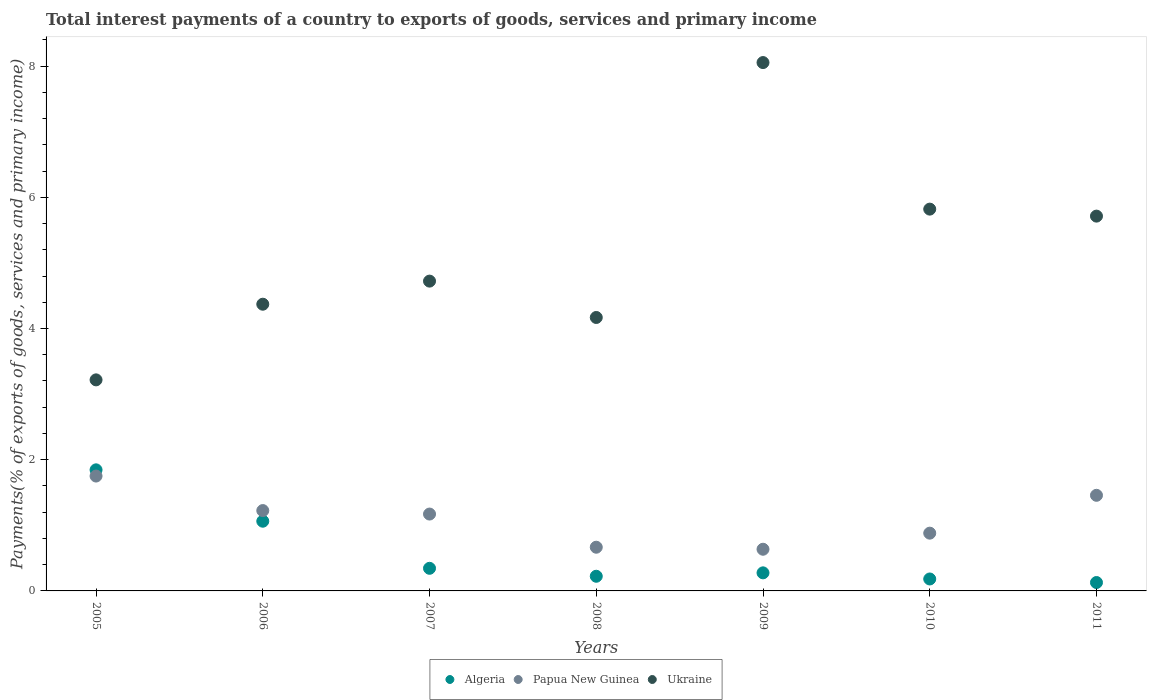How many different coloured dotlines are there?
Make the answer very short. 3. What is the total interest payments in Algeria in 2008?
Your answer should be compact. 0.22. Across all years, what is the maximum total interest payments in Papua New Guinea?
Keep it short and to the point. 1.75. Across all years, what is the minimum total interest payments in Papua New Guinea?
Provide a short and direct response. 0.64. In which year was the total interest payments in Papua New Guinea maximum?
Your answer should be compact. 2005. What is the total total interest payments in Algeria in the graph?
Give a very brief answer. 4.06. What is the difference between the total interest payments in Papua New Guinea in 2006 and that in 2010?
Your answer should be very brief. 0.34. What is the difference between the total interest payments in Algeria in 2008 and the total interest payments in Ukraine in 2009?
Provide a succinct answer. -7.83. What is the average total interest payments in Papua New Guinea per year?
Provide a short and direct response. 1.11. In the year 2010, what is the difference between the total interest payments in Algeria and total interest payments in Ukraine?
Keep it short and to the point. -5.64. In how many years, is the total interest payments in Ukraine greater than 3.2 %?
Provide a short and direct response. 7. What is the ratio of the total interest payments in Papua New Guinea in 2006 to that in 2007?
Offer a very short reply. 1.05. Is the total interest payments in Papua New Guinea in 2005 less than that in 2007?
Your answer should be very brief. No. What is the difference between the highest and the second highest total interest payments in Algeria?
Your response must be concise. 0.78. What is the difference between the highest and the lowest total interest payments in Ukraine?
Ensure brevity in your answer.  4.84. In how many years, is the total interest payments in Ukraine greater than the average total interest payments in Ukraine taken over all years?
Offer a very short reply. 3. Is it the case that in every year, the sum of the total interest payments in Papua New Guinea and total interest payments in Algeria  is greater than the total interest payments in Ukraine?
Keep it short and to the point. No. Is the total interest payments in Ukraine strictly greater than the total interest payments in Papua New Guinea over the years?
Keep it short and to the point. Yes. Is the total interest payments in Papua New Guinea strictly less than the total interest payments in Ukraine over the years?
Provide a short and direct response. Yes. What is the difference between two consecutive major ticks on the Y-axis?
Your response must be concise. 2. Are the values on the major ticks of Y-axis written in scientific E-notation?
Offer a very short reply. No. Does the graph contain any zero values?
Your response must be concise. No. Does the graph contain grids?
Give a very brief answer. No. How many legend labels are there?
Your answer should be compact. 3. How are the legend labels stacked?
Offer a terse response. Horizontal. What is the title of the graph?
Keep it short and to the point. Total interest payments of a country to exports of goods, services and primary income. What is the label or title of the X-axis?
Offer a very short reply. Years. What is the label or title of the Y-axis?
Your response must be concise. Payments(% of exports of goods, services and primary income). What is the Payments(% of exports of goods, services and primary income) in Algeria in 2005?
Offer a very short reply. 1.85. What is the Payments(% of exports of goods, services and primary income) in Papua New Guinea in 2005?
Offer a very short reply. 1.75. What is the Payments(% of exports of goods, services and primary income) of Ukraine in 2005?
Provide a short and direct response. 3.22. What is the Payments(% of exports of goods, services and primary income) in Algeria in 2006?
Your response must be concise. 1.06. What is the Payments(% of exports of goods, services and primary income) in Papua New Guinea in 2006?
Your response must be concise. 1.22. What is the Payments(% of exports of goods, services and primary income) in Ukraine in 2006?
Provide a short and direct response. 4.37. What is the Payments(% of exports of goods, services and primary income) in Algeria in 2007?
Your answer should be compact. 0.34. What is the Payments(% of exports of goods, services and primary income) in Papua New Guinea in 2007?
Keep it short and to the point. 1.17. What is the Payments(% of exports of goods, services and primary income) of Ukraine in 2007?
Keep it short and to the point. 4.72. What is the Payments(% of exports of goods, services and primary income) in Algeria in 2008?
Offer a very short reply. 0.22. What is the Payments(% of exports of goods, services and primary income) in Papua New Guinea in 2008?
Your answer should be very brief. 0.67. What is the Payments(% of exports of goods, services and primary income) in Ukraine in 2008?
Your answer should be compact. 4.17. What is the Payments(% of exports of goods, services and primary income) of Algeria in 2009?
Your answer should be very brief. 0.28. What is the Payments(% of exports of goods, services and primary income) in Papua New Guinea in 2009?
Your answer should be compact. 0.64. What is the Payments(% of exports of goods, services and primary income) in Ukraine in 2009?
Keep it short and to the point. 8.05. What is the Payments(% of exports of goods, services and primary income) in Algeria in 2010?
Keep it short and to the point. 0.18. What is the Payments(% of exports of goods, services and primary income) in Papua New Guinea in 2010?
Provide a succinct answer. 0.88. What is the Payments(% of exports of goods, services and primary income) of Ukraine in 2010?
Your answer should be compact. 5.82. What is the Payments(% of exports of goods, services and primary income) of Algeria in 2011?
Provide a short and direct response. 0.13. What is the Payments(% of exports of goods, services and primary income) in Papua New Guinea in 2011?
Offer a terse response. 1.46. What is the Payments(% of exports of goods, services and primary income) in Ukraine in 2011?
Your response must be concise. 5.71. Across all years, what is the maximum Payments(% of exports of goods, services and primary income) in Algeria?
Make the answer very short. 1.85. Across all years, what is the maximum Payments(% of exports of goods, services and primary income) in Papua New Guinea?
Provide a short and direct response. 1.75. Across all years, what is the maximum Payments(% of exports of goods, services and primary income) of Ukraine?
Your answer should be compact. 8.05. Across all years, what is the minimum Payments(% of exports of goods, services and primary income) in Algeria?
Your answer should be very brief. 0.13. Across all years, what is the minimum Payments(% of exports of goods, services and primary income) of Papua New Guinea?
Keep it short and to the point. 0.64. Across all years, what is the minimum Payments(% of exports of goods, services and primary income) in Ukraine?
Ensure brevity in your answer.  3.22. What is the total Payments(% of exports of goods, services and primary income) of Algeria in the graph?
Your answer should be very brief. 4.06. What is the total Payments(% of exports of goods, services and primary income) of Papua New Guinea in the graph?
Make the answer very short. 7.79. What is the total Payments(% of exports of goods, services and primary income) in Ukraine in the graph?
Provide a succinct answer. 36.06. What is the difference between the Payments(% of exports of goods, services and primary income) in Algeria in 2005 and that in 2006?
Offer a terse response. 0.78. What is the difference between the Payments(% of exports of goods, services and primary income) of Papua New Guinea in 2005 and that in 2006?
Make the answer very short. 0.53. What is the difference between the Payments(% of exports of goods, services and primary income) of Ukraine in 2005 and that in 2006?
Your response must be concise. -1.15. What is the difference between the Payments(% of exports of goods, services and primary income) in Algeria in 2005 and that in 2007?
Ensure brevity in your answer.  1.5. What is the difference between the Payments(% of exports of goods, services and primary income) in Papua New Guinea in 2005 and that in 2007?
Provide a short and direct response. 0.58. What is the difference between the Payments(% of exports of goods, services and primary income) of Ukraine in 2005 and that in 2007?
Ensure brevity in your answer.  -1.51. What is the difference between the Payments(% of exports of goods, services and primary income) in Algeria in 2005 and that in 2008?
Keep it short and to the point. 1.62. What is the difference between the Payments(% of exports of goods, services and primary income) of Papua New Guinea in 2005 and that in 2008?
Ensure brevity in your answer.  1.08. What is the difference between the Payments(% of exports of goods, services and primary income) in Ukraine in 2005 and that in 2008?
Offer a terse response. -0.95. What is the difference between the Payments(% of exports of goods, services and primary income) in Algeria in 2005 and that in 2009?
Offer a terse response. 1.57. What is the difference between the Payments(% of exports of goods, services and primary income) in Papua New Guinea in 2005 and that in 2009?
Provide a succinct answer. 1.12. What is the difference between the Payments(% of exports of goods, services and primary income) in Ukraine in 2005 and that in 2009?
Your answer should be compact. -4.84. What is the difference between the Payments(% of exports of goods, services and primary income) of Algeria in 2005 and that in 2010?
Your response must be concise. 1.66. What is the difference between the Payments(% of exports of goods, services and primary income) in Papua New Guinea in 2005 and that in 2010?
Keep it short and to the point. 0.87. What is the difference between the Payments(% of exports of goods, services and primary income) in Ukraine in 2005 and that in 2010?
Provide a succinct answer. -2.6. What is the difference between the Payments(% of exports of goods, services and primary income) of Algeria in 2005 and that in 2011?
Offer a terse response. 1.72. What is the difference between the Payments(% of exports of goods, services and primary income) of Papua New Guinea in 2005 and that in 2011?
Ensure brevity in your answer.  0.29. What is the difference between the Payments(% of exports of goods, services and primary income) in Ukraine in 2005 and that in 2011?
Provide a short and direct response. -2.5. What is the difference between the Payments(% of exports of goods, services and primary income) in Algeria in 2006 and that in 2007?
Ensure brevity in your answer.  0.72. What is the difference between the Payments(% of exports of goods, services and primary income) of Papua New Guinea in 2006 and that in 2007?
Your response must be concise. 0.05. What is the difference between the Payments(% of exports of goods, services and primary income) in Ukraine in 2006 and that in 2007?
Make the answer very short. -0.35. What is the difference between the Payments(% of exports of goods, services and primary income) in Algeria in 2006 and that in 2008?
Make the answer very short. 0.84. What is the difference between the Payments(% of exports of goods, services and primary income) in Papua New Guinea in 2006 and that in 2008?
Your response must be concise. 0.56. What is the difference between the Payments(% of exports of goods, services and primary income) of Ukraine in 2006 and that in 2008?
Provide a succinct answer. 0.2. What is the difference between the Payments(% of exports of goods, services and primary income) in Algeria in 2006 and that in 2009?
Offer a terse response. 0.79. What is the difference between the Payments(% of exports of goods, services and primary income) of Papua New Guinea in 2006 and that in 2009?
Give a very brief answer. 0.59. What is the difference between the Payments(% of exports of goods, services and primary income) in Ukraine in 2006 and that in 2009?
Provide a short and direct response. -3.68. What is the difference between the Payments(% of exports of goods, services and primary income) of Algeria in 2006 and that in 2010?
Offer a very short reply. 0.88. What is the difference between the Payments(% of exports of goods, services and primary income) in Papua New Guinea in 2006 and that in 2010?
Offer a terse response. 0.34. What is the difference between the Payments(% of exports of goods, services and primary income) of Ukraine in 2006 and that in 2010?
Your response must be concise. -1.45. What is the difference between the Payments(% of exports of goods, services and primary income) of Algeria in 2006 and that in 2011?
Make the answer very short. 0.93. What is the difference between the Payments(% of exports of goods, services and primary income) in Papua New Guinea in 2006 and that in 2011?
Keep it short and to the point. -0.23. What is the difference between the Payments(% of exports of goods, services and primary income) in Ukraine in 2006 and that in 2011?
Your answer should be compact. -1.34. What is the difference between the Payments(% of exports of goods, services and primary income) of Algeria in 2007 and that in 2008?
Ensure brevity in your answer.  0.12. What is the difference between the Payments(% of exports of goods, services and primary income) of Papua New Guinea in 2007 and that in 2008?
Provide a succinct answer. 0.51. What is the difference between the Payments(% of exports of goods, services and primary income) of Ukraine in 2007 and that in 2008?
Offer a terse response. 0.55. What is the difference between the Payments(% of exports of goods, services and primary income) of Algeria in 2007 and that in 2009?
Ensure brevity in your answer.  0.07. What is the difference between the Payments(% of exports of goods, services and primary income) in Papua New Guinea in 2007 and that in 2009?
Offer a terse response. 0.54. What is the difference between the Payments(% of exports of goods, services and primary income) in Ukraine in 2007 and that in 2009?
Provide a short and direct response. -3.33. What is the difference between the Payments(% of exports of goods, services and primary income) of Algeria in 2007 and that in 2010?
Make the answer very short. 0.16. What is the difference between the Payments(% of exports of goods, services and primary income) of Papua New Guinea in 2007 and that in 2010?
Offer a terse response. 0.29. What is the difference between the Payments(% of exports of goods, services and primary income) of Ukraine in 2007 and that in 2010?
Provide a short and direct response. -1.1. What is the difference between the Payments(% of exports of goods, services and primary income) of Algeria in 2007 and that in 2011?
Offer a terse response. 0.22. What is the difference between the Payments(% of exports of goods, services and primary income) in Papua New Guinea in 2007 and that in 2011?
Make the answer very short. -0.29. What is the difference between the Payments(% of exports of goods, services and primary income) of Ukraine in 2007 and that in 2011?
Offer a very short reply. -0.99. What is the difference between the Payments(% of exports of goods, services and primary income) of Algeria in 2008 and that in 2009?
Your response must be concise. -0.05. What is the difference between the Payments(% of exports of goods, services and primary income) in Papua New Guinea in 2008 and that in 2009?
Offer a terse response. 0.03. What is the difference between the Payments(% of exports of goods, services and primary income) in Ukraine in 2008 and that in 2009?
Ensure brevity in your answer.  -3.89. What is the difference between the Payments(% of exports of goods, services and primary income) of Algeria in 2008 and that in 2010?
Offer a terse response. 0.04. What is the difference between the Payments(% of exports of goods, services and primary income) of Papua New Guinea in 2008 and that in 2010?
Provide a short and direct response. -0.21. What is the difference between the Payments(% of exports of goods, services and primary income) in Ukraine in 2008 and that in 2010?
Keep it short and to the point. -1.65. What is the difference between the Payments(% of exports of goods, services and primary income) of Algeria in 2008 and that in 2011?
Offer a very short reply. 0.1. What is the difference between the Payments(% of exports of goods, services and primary income) of Papua New Guinea in 2008 and that in 2011?
Provide a short and direct response. -0.79. What is the difference between the Payments(% of exports of goods, services and primary income) of Ukraine in 2008 and that in 2011?
Make the answer very short. -1.54. What is the difference between the Payments(% of exports of goods, services and primary income) of Algeria in 2009 and that in 2010?
Provide a succinct answer. 0.09. What is the difference between the Payments(% of exports of goods, services and primary income) of Papua New Guinea in 2009 and that in 2010?
Make the answer very short. -0.25. What is the difference between the Payments(% of exports of goods, services and primary income) of Ukraine in 2009 and that in 2010?
Your answer should be very brief. 2.23. What is the difference between the Payments(% of exports of goods, services and primary income) of Algeria in 2009 and that in 2011?
Your answer should be very brief. 0.15. What is the difference between the Payments(% of exports of goods, services and primary income) of Papua New Guinea in 2009 and that in 2011?
Your response must be concise. -0.82. What is the difference between the Payments(% of exports of goods, services and primary income) of Ukraine in 2009 and that in 2011?
Keep it short and to the point. 2.34. What is the difference between the Payments(% of exports of goods, services and primary income) of Algeria in 2010 and that in 2011?
Give a very brief answer. 0.05. What is the difference between the Payments(% of exports of goods, services and primary income) of Papua New Guinea in 2010 and that in 2011?
Offer a very short reply. -0.58. What is the difference between the Payments(% of exports of goods, services and primary income) in Ukraine in 2010 and that in 2011?
Ensure brevity in your answer.  0.11. What is the difference between the Payments(% of exports of goods, services and primary income) in Algeria in 2005 and the Payments(% of exports of goods, services and primary income) in Papua New Guinea in 2006?
Offer a very short reply. 0.62. What is the difference between the Payments(% of exports of goods, services and primary income) in Algeria in 2005 and the Payments(% of exports of goods, services and primary income) in Ukraine in 2006?
Keep it short and to the point. -2.52. What is the difference between the Payments(% of exports of goods, services and primary income) of Papua New Guinea in 2005 and the Payments(% of exports of goods, services and primary income) of Ukraine in 2006?
Offer a very short reply. -2.62. What is the difference between the Payments(% of exports of goods, services and primary income) in Algeria in 2005 and the Payments(% of exports of goods, services and primary income) in Papua New Guinea in 2007?
Provide a succinct answer. 0.67. What is the difference between the Payments(% of exports of goods, services and primary income) in Algeria in 2005 and the Payments(% of exports of goods, services and primary income) in Ukraine in 2007?
Your answer should be very brief. -2.88. What is the difference between the Payments(% of exports of goods, services and primary income) of Papua New Guinea in 2005 and the Payments(% of exports of goods, services and primary income) of Ukraine in 2007?
Keep it short and to the point. -2.97. What is the difference between the Payments(% of exports of goods, services and primary income) in Algeria in 2005 and the Payments(% of exports of goods, services and primary income) in Papua New Guinea in 2008?
Provide a short and direct response. 1.18. What is the difference between the Payments(% of exports of goods, services and primary income) of Algeria in 2005 and the Payments(% of exports of goods, services and primary income) of Ukraine in 2008?
Provide a succinct answer. -2.32. What is the difference between the Payments(% of exports of goods, services and primary income) in Papua New Guinea in 2005 and the Payments(% of exports of goods, services and primary income) in Ukraine in 2008?
Provide a short and direct response. -2.42. What is the difference between the Payments(% of exports of goods, services and primary income) in Algeria in 2005 and the Payments(% of exports of goods, services and primary income) in Papua New Guinea in 2009?
Give a very brief answer. 1.21. What is the difference between the Payments(% of exports of goods, services and primary income) in Algeria in 2005 and the Payments(% of exports of goods, services and primary income) in Ukraine in 2009?
Your answer should be very brief. -6.21. What is the difference between the Payments(% of exports of goods, services and primary income) of Papua New Guinea in 2005 and the Payments(% of exports of goods, services and primary income) of Ukraine in 2009?
Ensure brevity in your answer.  -6.3. What is the difference between the Payments(% of exports of goods, services and primary income) of Algeria in 2005 and the Payments(% of exports of goods, services and primary income) of Papua New Guinea in 2010?
Provide a succinct answer. 0.97. What is the difference between the Payments(% of exports of goods, services and primary income) in Algeria in 2005 and the Payments(% of exports of goods, services and primary income) in Ukraine in 2010?
Keep it short and to the point. -3.97. What is the difference between the Payments(% of exports of goods, services and primary income) of Papua New Guinea in 2005 and the Payments(% of exports of goods, services and primary income) of Ukraine in 2010?
Provide a short and direct response. -4.07. What is the difference between the Payments(% of exports of goods, services and primary income) of Algeria in 2005 and the Payments(% of exports of goods, services and primary income) of Papua New Guinea in 2011?
Offer a very short reply. 0.39. What is the difference between the Payments(% of exports of goods, services and primary income) in Algeria in 2005 and the Payments(% of exports of goods, services and primary income) in Ukraine in 2011?
Provide a short and direct response. -3.87. What is the difference between the Payments(% of exports of goods, services and primary income) of Papua New Guinea in 2005 and the Payments(% of exports of goods, services and primary income) of Ukraine in 2011?
Offer a very short reply. -3.96. What is the difference between the Payments(% of exports of goods, services and primary income) in Algeria in 2006 and the Payments(% of exports of goods, services and primary income) in Papua New Guinea in 2007?
Your answer should be very brief. -0.11. What is the difference between the Payments(% of exports of goods, services and primary income) in Algeria in 2006 and the Payments(% of exports of goods, services and primary income) in Ukraine in 2007?
Your answer should be compact. -3.66. What is the difference between the Payments(% of exports of goods, services and primary income) in Papua New Guinea in 2006 and the Payments(% of exports of goods, services and primary income) in Ukraine in 2007?
Make the answer very short. -3.5. What is the difference between the Payments(% of exports of goods, services and primary income) in Algeria in 2006 and the Payments(% of exports of goods, services and primary income) in Papua New Guinea in 2008?
Your response must be concise. 0.4. What is the difference between the Payments(% of exports of goods, services and primary income) of Algeria in 2006 and the Payments(% of exports of goods, services and primary income) of Ukraine in 2008?
Your answer should be compact. -3.11. What is the difference between the Payments(% of exports of goods, services and primary income) of Papua New Guinea in 2006 and the Payments(% of exports of goods, services and primary income) of Ukraine in 2008?
Give a very brief answer. -2.94. What is the difference between the Payments(% of exports of goods, services and primary income) of Algeria in 2006 and the Payments(% of exports of goods, services and primary income) of Papua New Guinea in 2009?
Ensure brevity in your answer.  0.43. What is the difference between the Payments(% of exports of goods, services and primary income) of Algeria in 2006 and the Payments(% of exports of goods, services and primary income) of Ukraine in 2009?
Provide a short and direct response. -6.99. What is the difference between the Payments(% of exports of goods, services and primary income) in Papua New Guinea in 2006 and the Payments(% of exports of goods, services and primary income) in Ukraine in 2009?
Your answer should be very brief. -6.83. What is the difference between the Payments(% of exports of goods, services and primary income) in Algeria in 2006 and the Payments(% of exports of goods, services and primary income) in Papua New Guinea in 2010?
Give a very brief answer. 0.18. What is the difference between the Payments(% of exports of goods, services and primary income) of Algeria in 2006 and the Payments(% of exports of goods, services and primary income) of Ukraine in 2010?
Provide a short and direct response. -4.76. What is the difference between the Payments(% of exports of goods, services and primary income) of Papua New Guinea in 2006 and the Payments(% of exports of goods, services and primary income) of Ukraine in 2010?
Give a very brief answer. -4.59. What is the difference between the Payments(% of exports of goods, services and primary income) in Algeria in 2006 and the Payments(% of exports of goods, services and primary income) in Papua New Guinea in 2011?
Provide a succinct answer. -0.39. What is the difference between the Payments(% of exports of goods, services and primary income) of Algeria in 2006 and the Payments(% of exports of goods, services and primary income) of Ukraine in 2011?
Provide a succinct answer. -4.65. What is the difference between the Payments(% of exports of goods, services and primary income) of Papua New Guinea in 2006 and the Payments(% of exports of goods, services and primary income) of Ukraine in 2011?
Your answer should be very brief. -4.49. What is the difference between the Payments(% of exports of goods, services and primary income) of Algeria in 2007 and the Payments(% of exports of goods, services and primary income) of Papua New Guinea in 2008?
Provide a succinct answer. -0.32. What is the difference between the Payments(% of exports of goods, services and primary income) of Algeria in 2007 and the Payments(% of exports of goods, services and primary income) of Ukraine in 2008?
Offer a very short reply. -3.82. What is the difference between the Payments(% of exports of goods, services and primary income) of Papua New Guinea in 2007 and the Payments(% of exports of goods, services and primary income) of Ukraine in 2008?
Offer a very short reply. -3. What is the difference between the Payments(% of exports of goods, services and primary income) of Algeria in 2007 and the Payments(% of exports of goods, services and primary income) of Papua New Guinea in 2009?
Offer a very short reply. -0.29. What is the difference between the Payments(% of exports of goods, services and primary income) in Algeria in 2007 and the Payments(% of exports of goods, services and primary income) in Ukraine in 2009?
Make the answer very short. -7.71. What is the difference between the Payments(% of exports of goods, services and primary income) in Papua New Guinea in 2007 and the Payments(% of exports of goods, services and primary income) in Ukraine in 2009?
Your answer should be compact. -6.88. What is the difference between the Payments(% of exports of goods, services and primary income) in Algeria in 2007 and the Payments(% of exports of goods, services and primary income) in Papua New Guinea in 2010?
Your answer should be compact. -0.54. What is the difference between the Payments(% of exports of goods, services and primary income) in Algeria in 2007 and the Payments(% of exports of goods, services and primary income) in Ukraine in 2010?
Offer a terse response. -5.47. What is the difference between the Payments(% of exports of goods, services and primary income) of Papua New Guinea in 2007 and the Payments(% of exports of goods, services and primary income) of Ukraine in 2010?
Provide a short and direct response. -4.65. What is the difference between the Payments(% of exports of goods, services and primary income) in Algeria in 2007 and the Payments(% of exports of goods, services and primary income) in Papua New Guinea in 2011?
Make the answer very short. -1.11. What is the difference between the Payments(% of exports of goods, services and primary income) of Algeria in 2007 and the Payments(% of exports of goods, services and primary income) of Ukraine in 2011?
Offer a very short reply. -5.37. What is the difference between the Payments(% of exports of goods, services and primary income) in Papua New Guinea in 2007 and the Payments(% of exports of goods, services and primary income) in Ukraine in 2011?
Give a very brief answer. -4.54. What is the difference between the Payments(% of exports of goods, services and primary income) in Algeria in 2008 and the Payments(% of exports of goods, services and primary income) in Papua New Guinea in 2009?
Provide a succinct answer. -0.41. What is the difference between the Payments(% of exports of goods, services and primary income) of Algeria in 2008 and the Payments(% of exports of goods, services and primary income) of Ukraine in 2009?
Provide a short and direct response. -7.83. What is the difference between the Payments(% of exports of goods, services and primary income) of Papua New Guinea in 2008 and the Payments(% of exports of goods, services and primary income) of Ukraine in 2009?
Your answer should be very brief. -7.39. What is the difference between the Payments(% of exports of goods, services and primary income) of Algeria in 2008 and the Payments(% of exports of goods, services and primary income) of Papua New Guinea in 2010?
Ensure brevity in your answer.  -0.66. What is the difference between the Payments(% of exports of goods, services and primary income) of Algeria in 2008 and the Payments(% of exports of goods, services and primary income) of Ukraine in 2010?
Your answer should be compact. -5.6. What is the difference between the Payments(% of exports of goods, services and primary income) in Papua New Guinea in 2008 and the Payments(% of exports of goods, services and primary income) in Ukraine in 2010?
Offer a very short reply. -5.15. What is the difference between the Payments(% of exports of goods, services and primary income) of Algeria in 2008 and the Payments(% of exports of goods, services and primary income) of Papua New Guinea in 2011?
Offer a very short reply. -1.23. What is the difference between the Payments(% of exports of goods, services and primary income) of Algeria in 2008 and the Payments(% of exports of goods, services and primary income) of Ukraine in 2011?
Give a very brief answer. -5.49. What is the difference between the Payments(% of exports of goods, services and primary income) of Papua New Guinea in 2008 and the Payments(% of exports of goods, services and primary income) of Ukraine in 2011?
Offer a terse response. -5.05. What is the difference between the Payments(% of exports of goods, services and primary income) of Algeria in 2009 and the Payments(% of exports of goods, services and primary income) of Papua New Guinea in 2010?
Ensure brevity in your answer.  -0.6. What is the difference between the Payments(% of exports of goods, services and primary income) in Algeria in 2009 and the Payments(% of exports of goods, services and primary income) in Ukraine in 2010?
Your answer should be compact. -5.54. What is the difference between the Payments(% of exports of goods, services and primary income) in Papua New Guinea in 2009 and the Payments(% of exports of goods, services and primary income) in Ukraine in 2010?
Your answer should be compact. -5.18. What is the difference between the Payments(% of exports of goods, services and primary income) in Algeria in 2009 and the Payments(% of exports of goods, services and primary income) in Papua New Guinea in 2011?
Provide a succinct answer. -1.18. What is the difference between the Payments(% of exports of goods, services and primary income) of Algeria in 2009 and the Payments(% of exports of goods, services and primary income) of Ukraine in 2011?
Provide a short and direct response. -5.44. What is the difference between the Payments(% of exports of goods, services and primary income) of Papua New Guinea in 2009 and the Payments(% of exports of goods, services and primary income) of Ukraine in 2011?
Offer a terse response. -5.08. What is the difference between the Payments(% of exports of goods, services and primary income) in Algeria in 2010 and the Payments(% of exports of goods, services and primary income) in Papua New Guinea in 2011?
Your answer should be compact. -1.28. What is the difference between the Payments(% of exports of goods, services and primary income) in Algeria in 2010 and the Payments(% of exports of goods, services and primary income) in Ukraine in 2011?
Offer a terse response. -5.53. What is the difference between the Payments(% of exports of goods, services and primary income) in Papua New Guinea in 2010 and the Payments(% of exports of goods, services and primary income) in Ukraine in 2011?
Offer a very short reply. -4.83. What is the average Payments(% of exports of goods, services and primary income) in Algeria per year?
Provide a short and direct response. 0.58. What is the average Payments(% of exports of goods, services and primary income) of Papua New Guinea per year?
Your answer should be very brief. 1.11. What is the average Payments(% of exports of goods, services and primary income) in Ukraine per year?
Provide a succinct answer. 5.15. In the year 2005, what is the difference between the Payments(% of exports of goods, services and primary income) of Algeria and Payments(% of exports of goods, services and primary income) of Papua New Guinea?
Offer a terse response. 0.09. In the year 2005, what is the difference between the Payments(% of exports of goods, services and primary income) in Algeria and Payments(% of exports of goods, services and primary income) in Ukraine?
Provide a succinct answer. -1.37. In the year 2005, what is the difference between the Payments(% of exports of goods, services and primary income) in Papua New Guinea and Payments(% of exports of goods, services and primary income) in Ukraine?
Your answer should be very brief. -1.47. In the year 2006, what is the difference between the Payments(% of exports of goods, services and primary income) of Algeria and Payments(% of exports of goods, services and primary income) of Papua New Guinea?
Provide a succinct answer. -0.16. In the year 2006, what is the difference between the Payments(% of exports of goods, services and primary income) of Algeria and Payments(% of exports of goods, services and primary income) of Ukraine?
Your answer should be compact. -3.31. In the year 2006, what is the difference between the Payments(% of exports of goods, services and primary income) of Papua New Guinea and Payments(% of exports of goods, services and primary income) of Ukraine?
Provide a short and direct response. -3.15. In the year 2007, what is the difference between the Payments(% of exports of goods, services and primary income) of Algeria and Payments(% of exports of goods, services and primary income) of Papua New Guinea?
Provide a short and direct response. -0.83. In the year 2007, what is the difference between the Payments(% of exports of goods, services and primary income) of Algeria and Payments(% of exports of goods, services and primary income) of Ukraine?
Ensure brevity in your answer.  -4.38. In the year 2007, what is the difference between the Payments(% of exports of goods, services and primary income) in Papua New Guinea and Payments(% of exports of goods, services and primary income) in Ukraine?
Offer a terse response. -3.55. In the year 2008, what is the difference between the Payments(% of exports of goods, services and primary income) of Algeria and Payments(% of exports of goods, services and primary income) of Papua New Guinea?
Your response must be concise. -0.44. In the year 2008, what is the difference between the Payments(% of exports of goods, services and primary income) in Algeria and Payments(% of exports of goods, services and primary income) in Ukraine?
Offer a very short reply. -3.94. In the year 2008, what is the difference between the Payments(% of exports of goods, services and primary income) of Papua New Guinea and Payments(% of exports of goods, services and primary income) of Ukraine?
Ensure brevity in your answer.  -3.5. In the year 2009, what is the difference between the Payments(% of exports of goods, services and primary income) of Algeria and Payments(% of exports of goods, services and primary income) of Papua New Guinea?
Provide a succinct answer. -0.36. In the year 2009, what is the difference between the Payments(% of exports of goods, services and primary income) of Algeria and Payments(% of exports of goods, services and primary income) of Ukraine?
Your answer should be compact. -7.78. In the year 2009, what is the difference between the Payments(% of exports of goods, services and primary income) in Papua New Guinea and Payments(% of exports of goods, services and primary income) in Ukraine?
Provide a succinct answer. -7.42. In the year 2010, what is the difference between the Payments(% of exports of goods, services and primary income) of Algeria and Payments(% of exports of goods, services and primary income) of Papua New Guinea?
Offer a very short reply. -0.7. In the year 2010, what is the difference between the Payments(% of exports of goods, services and primary income) in Algeria and Payments(% of exports of goods, services and primary income) in Ukraine?
Make the answer very short. -5.64. In the year 2010, what is the difference between the Payments(% of exports of goods, services and primary income) in Papua New Guinea and Payments(% of exports of goods, services and primary income) in Ukraine?
Offer a terse response. -4.94. In the year 2011, what is the difference between the Payments(% of exports of goods, services and primary income) in Algeria and Payments(% of exports of goods, services and primary income) in Papua New Guinea?
Make the answer very short. -1.33. In the year 2011, what is the difference between the Payments(% of exports of goods, services and primary income) of Algeria and Payments(% of exports of goods, services and primary income) of Ukraine?
Your response must be concise. -5.58. In the year 2011, what is the difference between the Payments(% of exports of goods, services and primary income) of Papua New Guinea and Payments(% of exports of goods, services and primary income) of Ukraine?
Offer a very short reply. -4.26. What is the ratio of the Payments(% of exports of goods, services and primary income) in Algeria in 2005 to that in 2006?
Your response must be concise. 1.74. What is the ratio of the Payments(% of exports of goods, services and primary income) in Papua New Guinea in 2005 to that in 2006?
Your response must be concise. 1.43. What is the ratio of the Payments(% of exports of goods, services and primary income) in Ukraine in 2005 to that in 2006?
Your answer should be very brief. 0.74. What is the ratio of the Payments(% of exports of goods, services and primary income) in Algeria in 2005 to that in 2007?
Your answer should be very brief. 5.35. What is the ratio of the Payments(% of exports of goods, services and primary income) of Papua New Guinea in 2005 to that in 2007?
Offer a terse response. 1.49. What is the ratio of the Payments(% of exports of goods, services and primary income) of Ukraine in 2005 to that in 2007?
Offer a terse response. 0.68. What is the ratio of the Payments(% of exports of goods, services and primary income) in Algeria in 2005 to that in 2008?
Provide a short and direct response. 8.26. What is the ratio of the Payments(% of exports of goods, services and primary income) of Papua New Guinea in 2005 to that in 2008?
Your response must be concise. 2.63. What is the ratio of the Payments(% of exports of goods, services and primary income) of Ukraine in 2005 to that in 2008?
Your response must be concise. 0.77. What is the ratio of the Payments(% of exports of goods, services and primary income) in Algeria in 2005 to that in 2009?
Give a very brief answer. 6.7. What is the ratio of the Payments(% of exports of goods, services and primary income) in Papua New Guinea in 2005 to that in 2009?
Your response must be concise. 2.76. What is the ratio of the Payments(% of exports of goods, services and primary income) of Ukraine in 2005 to that in 2009?
Your answer should be very brief. 0.4. What is the ratio of the Payments(% of exports of goods, services and primary income) in Algeria in 2005 to that in 2010?
Your answer should be very brief. 10.14. What is the ratio of the Payments(% of exports of goods, services and primary income) in Papua New Guinea in 2005 to that in 2010?
Offer a terse response. 1.99. What is the ratio of the Payments(% of exports of goods, services and primary income) in Ukraine in 2005 to that in 2010?
Provide a succinct answer. 0.55. What is the ratio of the Payments(% of exports of goods, services and primary income) of Algeria in 2005 to that in 2011?
Give a very brief answer. 14.42. What is the ratio of the Payments(% of exports of goods, services and primary income) in Papua New Guinea in 2005 to that in 2011?
Your response must be concise. 1.2. What is the ratio of the Payments(% of exports of goods, services and primary income) in Ukraine in 2005 to that in 2011?
Offer a very short reply. 0.56. What is the ratio of the Payments(% of exports of goods, services and primary income) in Algeria in 2006 to that in 2007?
Provide a short and direct response. 3.08. What is the ratio of the Payments(% of exports of goods, services and primary income) in Papua New Guinea in 2006 to that in 2007?
Your answer should be compact. 1.05. What is the ratio of the Payments(% of exports of goods, services and primary income) in Ukraine in 2006 to that in 2007?
Offer a very short reply. 0.93. What is the ratio of the Payments(% of exports of goods, services and primary income) in Algeria in 2006 to that in 2008?
Make the answer very short. 4.75. What is the ratio of the Payments(% of exports of goods, services and primary income) in Papua New Guinea in 2006 to that in 2008?
Provide a succinct answer. 1.84. What is the ratio of the Payments(% of exports of goods, services and primary income) in Ukraine in 2006 to that in 2008?
Offer a very short reply. 1.05. What is the ratio of the Payments(% of exports of goods, services and primary income) in Algeria in 2006 to that in 2009?
Provide a short and direct response. 3.86. What is the ratio of the Payments(% of exports of goods, services and primary income) of Papua New Guinea in 2006 to that in 2009?
Ensure brevity in your answer.  1.93. What is the ratio of the Payments(% of exports of goods, services and primary income) in Ukraine in 2006 to that in 2009?
Your answer should be compact. 0.54. What is the ratio of the Payments(% of exports of goods, services and primary income) in Algeria in 2006 to that in 2010?
Provide a succinct answer. 5.84. What is the ratio of the Payments(% of exports of goods, services and primary income) of Papua New Guinea in 2006 to that in 2010?
Your answer should be compact. 1.39. What is the ratio of the Payments(% of exports of goods, services and primary income) of Ukraine in 2006 to that in 2010?
Your answer should be compact. 0.75. What is the ratio of the Payments(% of exports of goods, services and primary income) of Algeria in 2006 to that in 2011?
Keep it short and to the point. 8.3. What is the ratio of the Payments(% of exports of goods, services and primary income) in Papua New Guinea in 2006 to that in 2011?
Your response must be concise. 0.84. What is the ratio of the Payments(% of exports of goods, services and primary income) of Ukraine in 2006 to that in 2011?
Ensure brevity in your answer.  0.77. What is the ratio of the Payments(% of exports of goods, services and primary income) of Algeria in 2007 to that in 2008?
Your response must be concise. 1.54. What is the ratio of the Payments(% of exports of goods, services and primary income) in Papua New Guinea in 2007 to that in 2008?
Ensure brevity in your answer.  1.76. What is the ratio of the Payments(% of exports of goods, services and primary income) in Ukraine in 2007 to that in 2008?
Your answer should be compact. 1.13. What is the ratio of the Payments(% of exports of goods, services and primary income) in Algeria in 2007 to that in 2009?
Provide a succinct answer. 1.25. What is the ratio of the Payments(% of exports of goods, services and primary income) in Papua New Guinea in 2007 to that in 2009?
Keep it short and to the point. 1.84. What is the ratio of the Payments(% of exports of goods, services and primary income) in Ukraine in 2007 to that in 2009?
Provide a succinct answer. 0.59. What is the ratio of the Payments(% of exports of goods, services and primary income) of Algeria in 2007 to that in 2010?
Your answer should be compact. 1.89. What is the ratio of the Payments(% of exports of goods, services and primary income) of Papua New Guinea in 2007 to that in 2010?
Ensure brevity in your answer.  1.33. What is the ratio of the Payments(% of exports of goods, services and primary income) in Ukraine in 2007 to that in 2010?
Ensure brevity in your answer.  0.81. What is the ratio of the Payments(% of exports of goods, services and primary income) in Algeria in 2007 to that in 2011?
Give a very brief answer. 2.69. What is the ratio of the Payments(% of exports of goods, services and primary income) in Papua New Guinea in 2007 to that in 2011?
Provide a succinct answer. 0.8. What is the ratio of the Payments(% of exports of goods, services and primary income) of Ukraine in 2007 to that in 2011?
Offer a very short reply. 0.83. What is the ratio of the Payments(% of exports of goods, services and primary income) in Algeria in 2008 to that in 2009?
Keep it short and to the point. 0.81. What is the ratio of the Payments(% of exports of goods, services and primary income) of Papua New Guinea in 2008 to that in 2009?
Your answer should be compact. 1.05. What is the ratio of the Payments(% of exports of goods, services and primary income) in Ukraine in 2008 to that in 2009?
Keep it short and to the point. 0.52. What is the ratio of the Payments(% of exports of goods, services and primary income) of Algeria in 2008 to that in 2010?
Offer a terse response. 1.23. What is the ratio of the Payments(% of exports of goods, services and primary income) in Papua New Guinea in 2008 to that in 2010?
Your response must be concise. 0.76. What is the ratio of the Payments(% of exports of goods, services and primary income) of Ukraine in 2008 to that in 2010?
Keep it short and to the point. 0.72. What is the ratio of the Payments(% of exports of goods, services and primary income) of Algeria in 2008 to that in 2011?
Make the answer very short. 1.75. What is the ratio of the Payments(% of exports of goods, services and primary income) of Papua New Guinea in 2008 to that in 2011?
Your answer should be very brief. 0.46. What is the ratio of the Payments(% of exports of goods, services and primary income) of Ukraine in 2008 to that in 2011?
Ensure brevity in your answer.  0.73. What is the ratio of the Payments(% of exports of goods, services and primary income) in Algeria in 2009 to that in 2010?
Offer a very short reply. 1.51. What is the ratio of the Payments(% of exports of goods, services and primary income) in Papua New Guinea in 2009 to that in 2010?
Make the answer very short. 0.72. What is the ratio of the Payments(% of exports of goods, services and primary income) of Ukraine in 2009 to that in 2010?
Keep it short and to the point. 1.38. What is the ratio of the Payments(% of exports of goods, services and primary income) of Algeria in 2009 to that in 2011?
Your answer should be compact. 2.15. What is the ratio of the Payments(% of exports of goods, services and primary income) of Papua New Guinea in 2009 to that in 2011?
Keep it short and to the point. 0.44. What is the ratio of the Payments(% of exports of goods, services and primary income) of Ukraine in 2009 to that in 2011?
Your answer should be compact. 1.41. What is the ratio of the Payments(% of exports of goods, services and primary income) in Algeria in 2010 to that in 2011?
Your answer should be compact. 1.42. What is the ratio of the Payments(% of exports of goods, services and primary income) of Papua New Guinea in 2010 to that in 2011?
Offer a very short reply. 0.6. What is the ratio of the Payments(% of exports of goods, services and primary income) in Ukraine in 2010 to that in 2011?
Ensure brevity in your answer.  1.02. What is the difference between the highest and the second highest Payments(% of exports of goods, services and primary income) of Algeria?
Your answer should be very brief. 0.78. What is the difference between the highest and the second highest Payments(% of exports of goods, services and primary income) of Papua New Guinea?
Offer a terse response. 0.29. What is the difference between the highest and the second highest Payments(% of exports of goods, services and primary income) of Ukraine?
Your response must be concise. 2.23. What is the difference between the highest and the lowest Payments(% of exports of goods, services and primary income) in Algeria?
Your answer should be compact. 1.72. What is the difference between the highest and the lowest Payments(% of exports of goods, services and primary income) in Papua New Guinea?
Your answer should be very brief. 1.12. What is the difference between the highest and the lowest Payments(% of exports of goods, services and primary income) in Ukraine?
Your response must be concise. 4.84. 